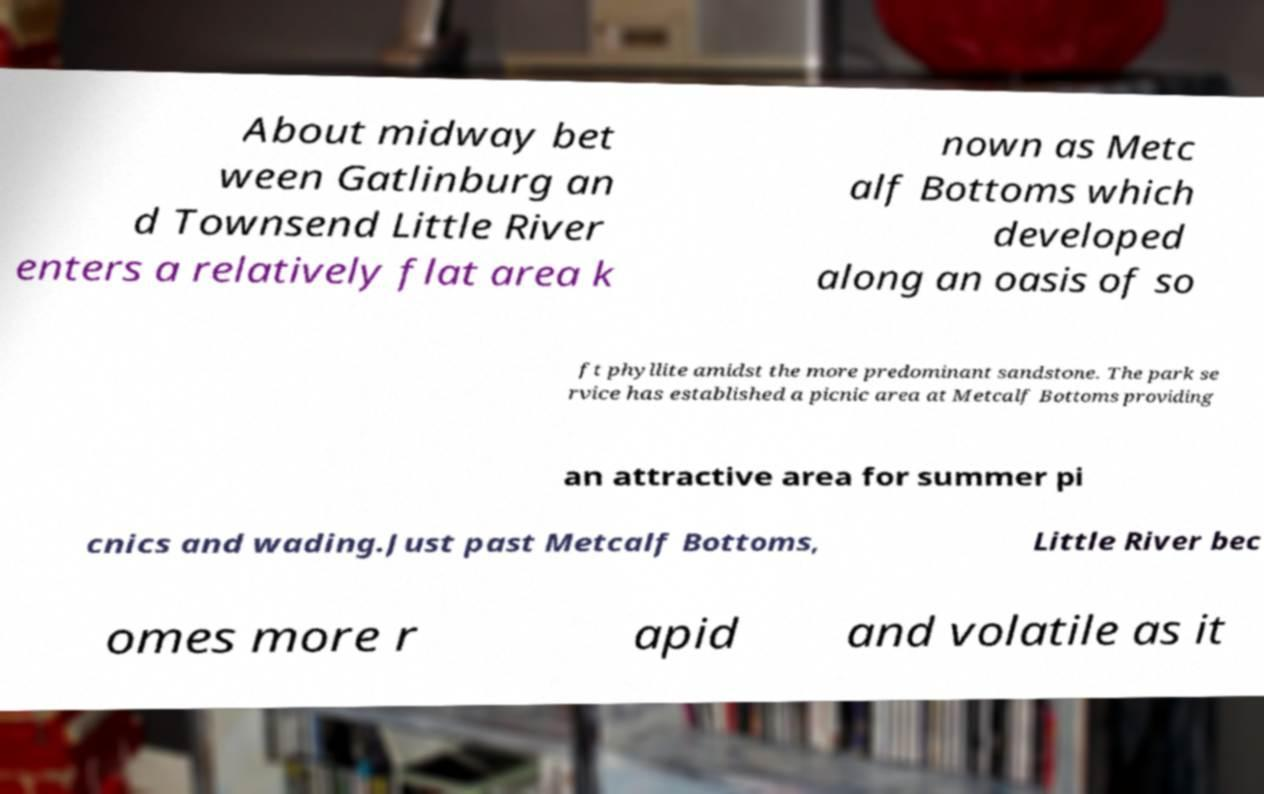Please identify and transcribe the text found in this image. About midway bet ween Gatlinburg an d Townsend Little River enters a relatively flat area k nown as Metc alf Bottoms which developed along an oasis of so ft phyllite amidst the more predominant sandstone. The park se rvice has established a picnic area at Metcalf Bottoms providing an attractive area for summer pi cnics and wading.Just past Metcalf Bottoms, Little River bec omes more r apid and volatile as it 